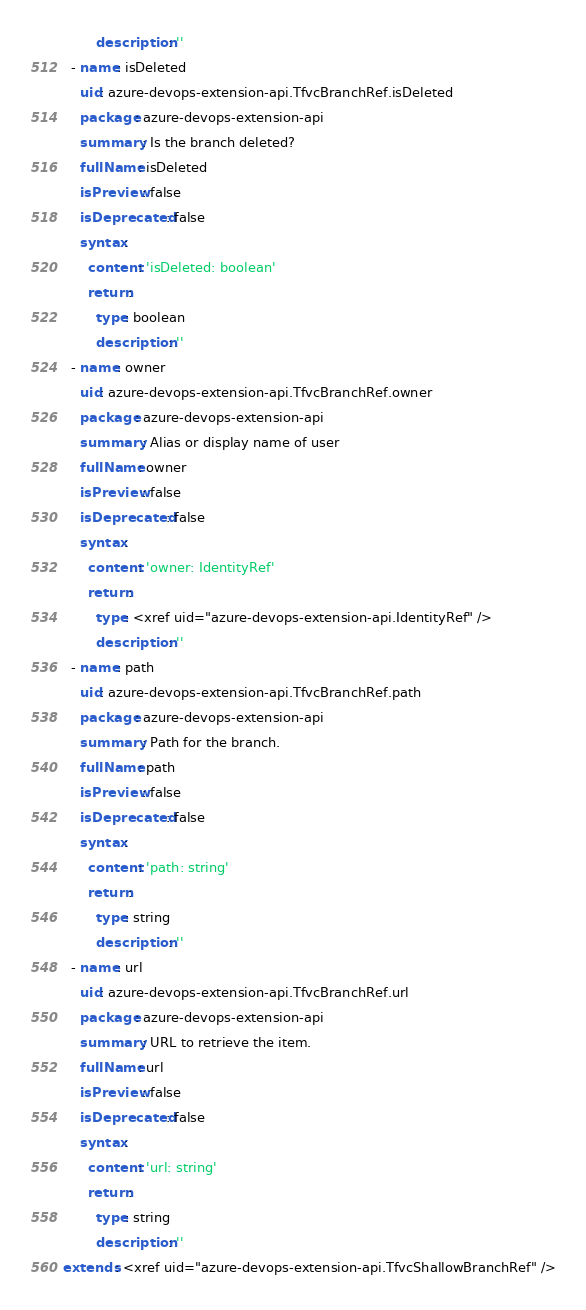<code> <loc_0><loc_0><loc_500><loc_500><_YAML_>        description: ''
  - name: isDeleted
    uid: azure-devops-extension-api.TfvcBranchRef.isDeleted
    package: azure-devops-extension-api
    summary: Is the branch deleted?
    fullName: isDeleted
    isPreview: false
    isDeprecated: false
    syntax:
      content: 'isDeleted: boolean'
      return:
        type: boolean
        description: ''
  - name: owner
    uid: azure-devops-extension-api.TfvcBranchRef.owner
    package: azure-devops-extension-api
    summary: Alias or display name of user
    fullName: owner
    isPreview: false
    isDeprecated: false
    syntax:
      content: 'owner: IdentityRef'
      return:
        type: <xref uid="azure-devops-extension-api.IdentityRef" />
        description: ''
  - name: path
    uid: azure-devops-extension-api.TfvcBranchRef.path
    package: azure-devops-extension-api
    summary: Path for the branch.
    fullName: path
    isPreview: false
    isDeprecated: false
    syntax:
      content: 'path: string'
      return:
        type: string
        description: ''
  - name: url
    uid: azure-devops-extension-api.TfvcBranchRef.url
    package: azure-devops-extension-api
    summary: URL to retrieve the item.
    fullName: url
    isPreview: false
    isDeprecated: false
    syntax:
      content: 'url: string'
      return:
        type: string
        description: ''
extends: <xref uid="azure-devops-extension-api.TfvcShallowBranchRef" />
</code> 